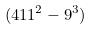Convert formula to latex. <formula><loc_0><loc_0><loc_500><loc_500>( 4 1 1 ^ { 2 } - 9 ^ { 3 } )</formula> 